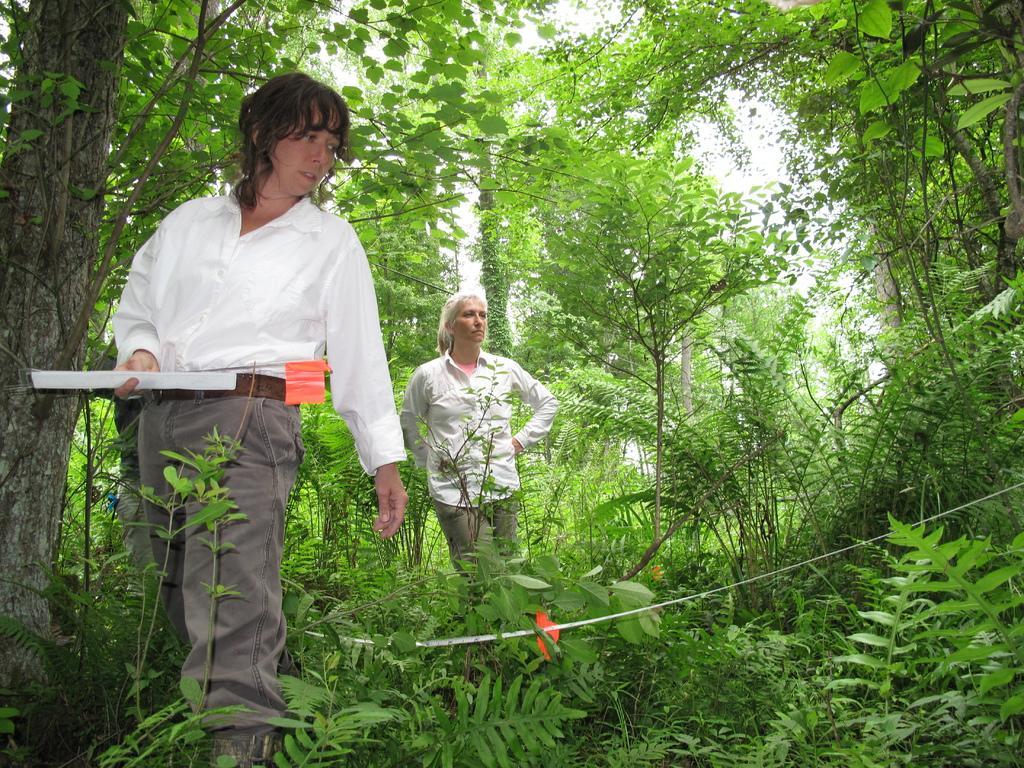Describe this image in one or two sentences. In this image we can see two women. They are wearing white shirt and pant. One woman is holding an object in her hand. In the background, we can see trees. At the bottom of the image, plants are there and one white color rope is present. 